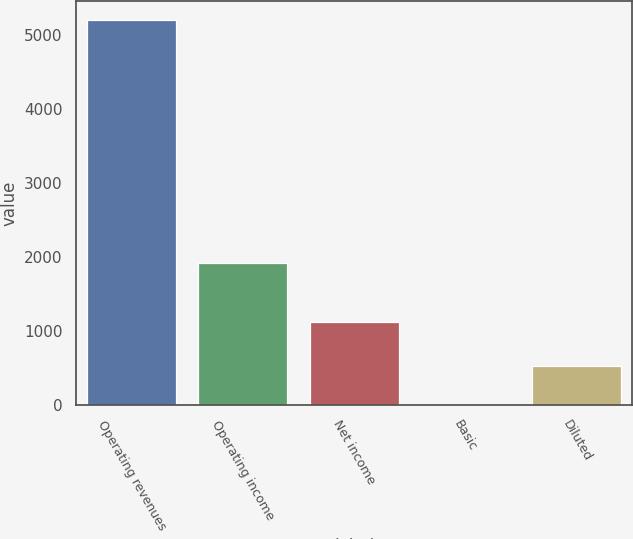Convert chart to OTSL. <chart><loc_0><loc_0><loc_500><loc_500><bar_chart><fcel>Operating revenues<fcel>Operating income<fcel>Net income<fcel>Basic<fcel>Diluted<nl><fcel>5208<fcel>1918<fcel>1117<fcel>1.31<fcel>521.98<nl></chart> 